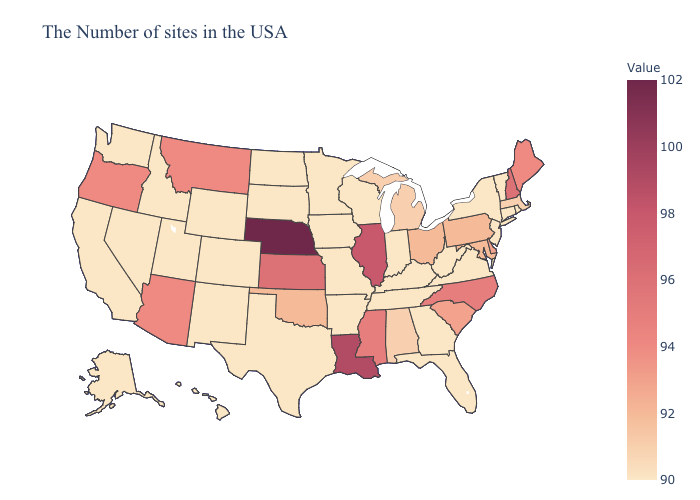Which states have the highest value in the USA?
Be succinct. Nebraska. Which states have the highest value in the USA?
Write a very short answer. Nebraska. Which states have the highest value in the USA?
Be succinct. Nebraska. Does Kansas have the highest value in the MidWest?
Keep it brief. No. 